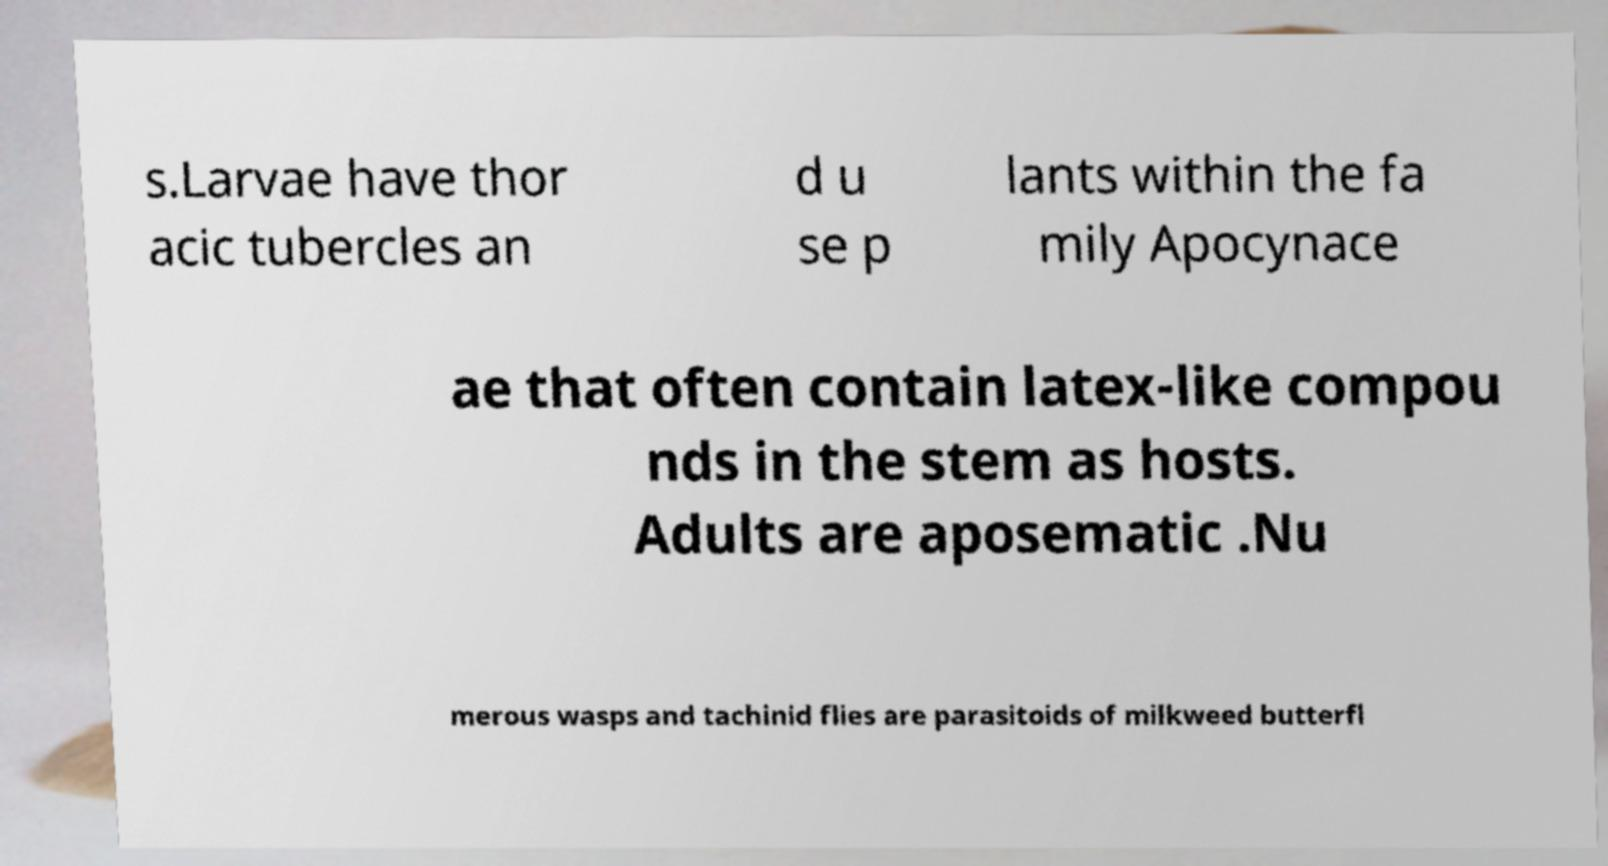There's text embedded in this image that I need extracted. Can you transcribe it verbatim? s.Larvae have thor acic tubercles an d u se p lants within the fa mily Apocynace ae that often contain latex-like compou nds in the stem as hosts. Adults are aposematic .Nu merous wasps and tachinid flies are parasitoids of milkweed butterfl 